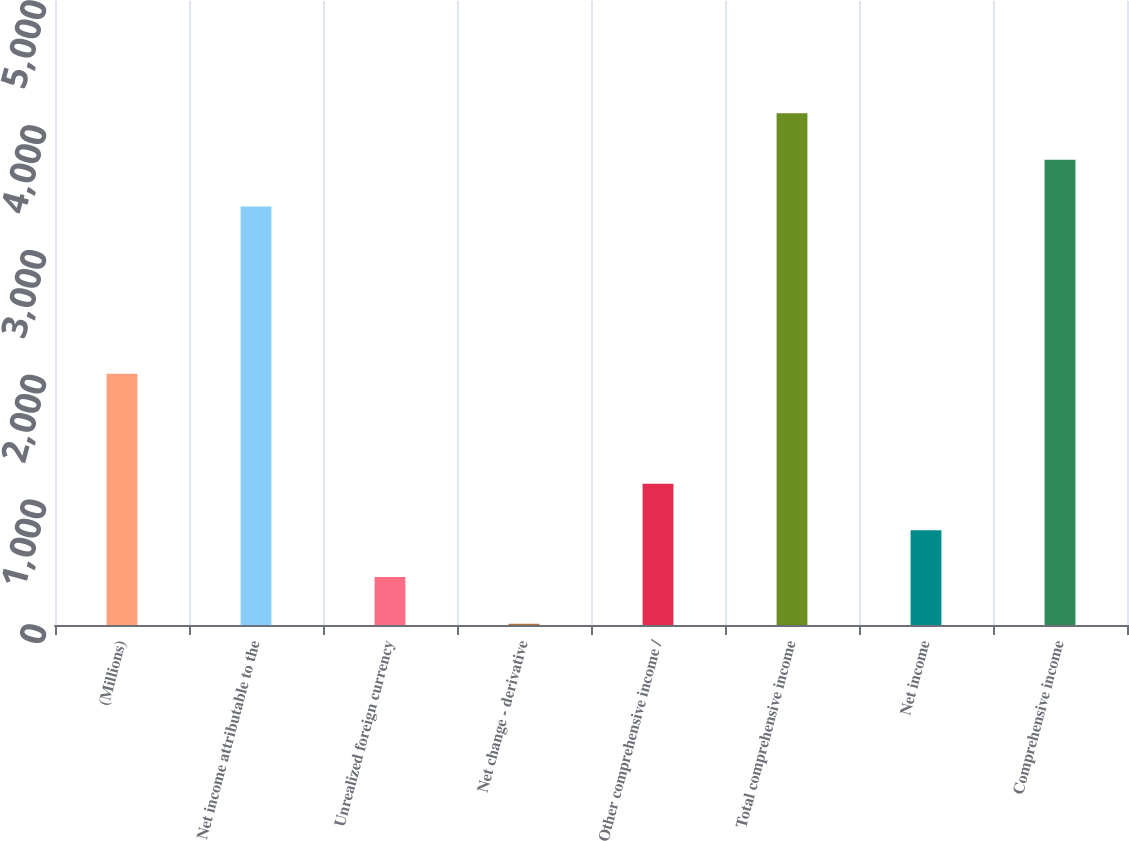<chart> <loc_0><loc_0><loc_500><loc_500><bar_chart><fcel>(Millions)<fcel>Net income attributable to the<fcel>Unrealized foreign currency<fcel>Net change - derivative<fcel>Other comprehensive income /<fcel>Total comprehensive income<fcel>Net income<fcel>Comprehensive income<nl><fcel>2013<fcel>3353<fcel>384.2<fcel>10<fcel>1132.6<fcel>4101.4<fcel>758.4<fcel>3727.2<nl></chart> 